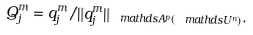Convert formula to latex. <formula><loc_0><loc_0><loc_500><loc_500>Q _ { j } ^ { m } = q _ { j } ^ { m } / \| q _ { j } ^ { m } \| _ { \ m a t h d s { A } ^ { p } ( \ m a t h d s { U } ^ { n } ) } .</formula> 